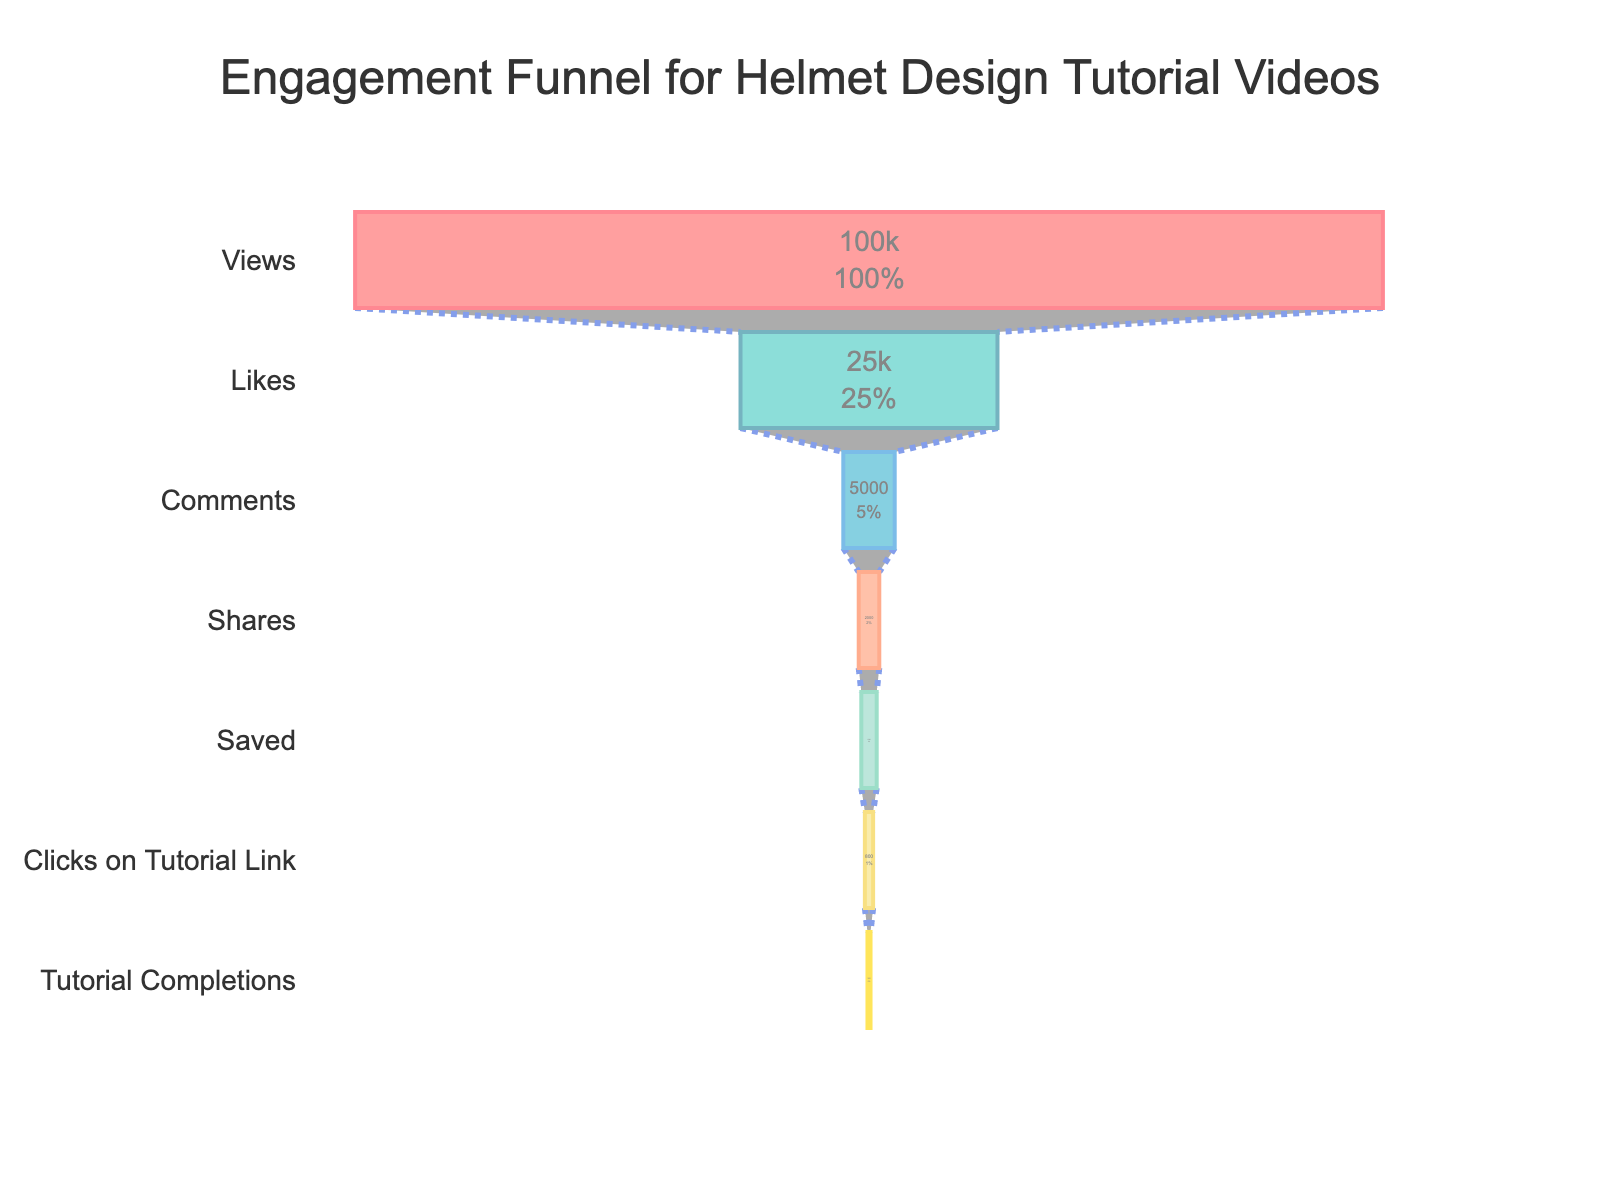What is the title of the figure? The title is located at the top center of the figure, displaying the main topic or purpose of the chart.
Answer: Engagement Funnel for Helmet Design Tutorial Videos How many total stages are represented in the funnel? Count the unique stages listed on the y-axis of the funnel chart.
Answer: 7 Which stage has the highest count? Identify the stage with the longest bar in the figure.
Answer: Views What is the percentage of Likes from the initial stage (Views)? The percentage is shown inside the Likes bar in relation to the initial stage Views count.
Answer: 25% What is the decrease in count from Comments to Shares? Subtract the count of Shares from the count of Comments as shown in the figure.
Answer: 3000 How many more people clicked on the tutorial link than completed the tutorial? Subtract the count of "Tutorial Completions" from the count of "Clicks on Tutorial Link".
Answer: 500 Which stage has the smallest count in the funnel? Identify the stage with the shortest bar in the funnel chart.
Answer: Tutorial Completions What is the cumulative percentage decrease from Views to Tutorial Completions? Calculate the percentage of each stage from the initial count and subtract these percentages successively from 100%.
Answer: 0.3% How does the number of Saves compare to the number of Shares? Identify the counts for both Saves and Shares and compare their values.
Answer: Saves are less than Shares What is the sum of the counts for Comments, Shares, Saved, Clicks on Tutorial Link, and Tutorial Completions? Add the counts for Comments, Shares, Saved, Clicks on Tutorial Link, and Tutorial Completions together.
Answer: 12300 